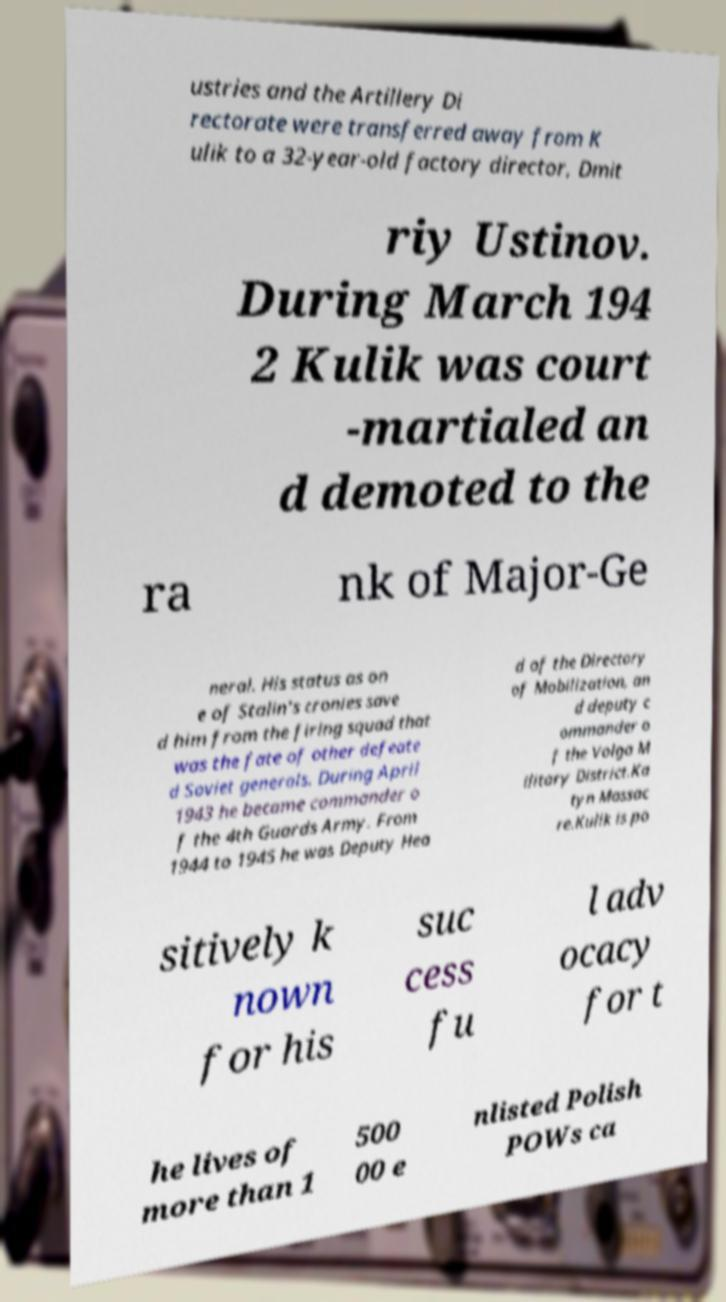Please identify and transcribe the text found in this image. ustries and the Artillery Di rectorate were transferred away from K ulik to a 32-year-old factory director, Dmit riy Ustinov. During March 194 2 Kulik was court -martialed an d demoted to the ra nk of Major-Ge neral. His status as on e of Stalin's cronies save d him from the firing squad that was the fate of other defeate d Soviet generals. During April 1943 he became commander o f the 4th Guards Army. From 1944 to 1945 he was Deputy Hea d of the Directory of Mobilization, an d deputy c ommander o f the Volga M ilitary District.Ka tyn Massac re.Kulik is po sitively k nown for his suc cess fu l adv ocacy for t he lives of more than 1 500 00 e nlisted Polish POWs ca 